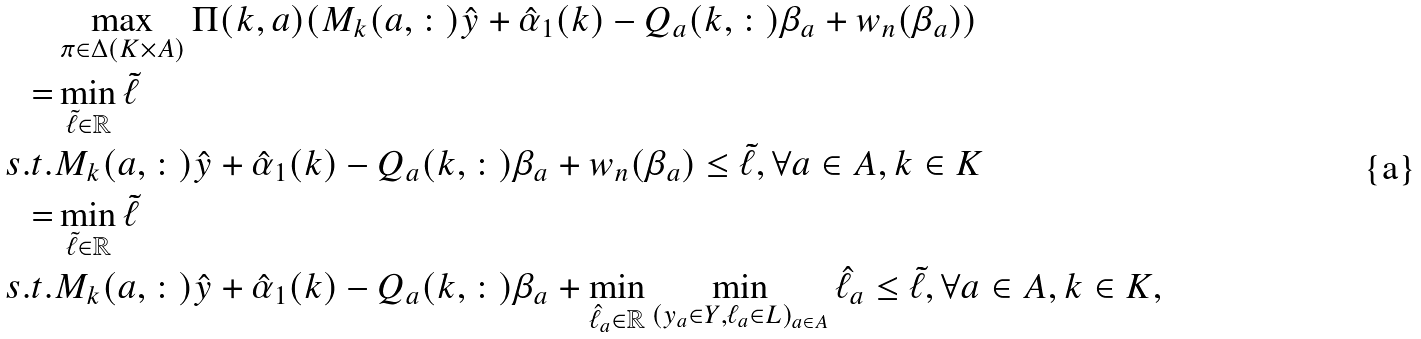Convert formula to latex. <formula><loc_0><loc_0><loc_500><loc_500>& \max _ { \pi \in \Delta ( K \times A ) } \Pi ( k , a ) ( M _ { k } ( a , \colon ) \hat { y } + \hat { \alpha } _ { 1 } ( k ) - Q _ { a } ( k , \colon ) \beta _ { a } + w _ { n } ( \beta _ { a } ) ) \\ = & \min _ { \tilde { \ell } \in \mathbb { R } } \tilde { \ell } \\ s . t . & M _ { k } ( a , \colon ) \hat { y } + \hat { \alpha } _ { 1 } ( k ) - Q _ { a } ( k , \colon ) \beta _ { a } + w _ { n } ( \beta _ { a } ) \leq \tilde { \ell } , \forall a \in A , k \in K \\ = & \min _ { \tilde { \ell } \in \mathbb { R } } \tilde { \ell } \\ s . t . & M _ { k } ( a , \colon ) \hat { y } + \hat { \alpha } _ { 1 } ( k ) - Q _ { a } ( k , \colon ) \beta _ { a } + \min _ { \hat { \ell } _ { a } \in \mathbb { R } } \min _ { ( y _ { a } \in Y , \ell _ { a } \in L ) _ { a \in A } } \hat { \ell } _ { a } \leq \tilde { \ell } , \forall a \in A , k \in K ,</formula> 